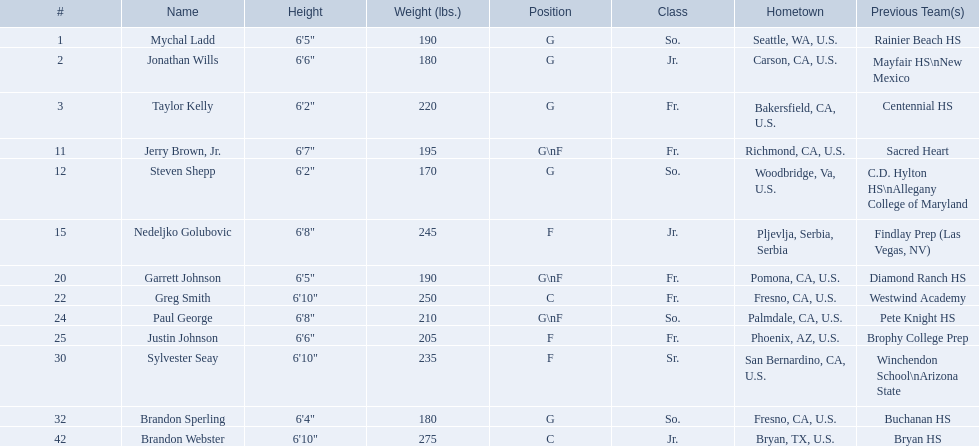What grade level was each team member in during the 2009-10 fresno state bulldogs? So., Jr., Fr., Fr., So., Jr., Fr., Fr., So., Fr., Sr., So., Jr. Which of these members was not from the us? Jr. Who was that player? Nedeljko Golubovic. Which team members play as forwards? Nedeljko Golubovic, Paul George, Justin Johnson, Sylvester Seay. What are their heights? Nedeljko Golubovic, 6'8", Paul George, 6'8", Justin Johnson, 6'6", Sylvester Seay, 6'10". Out of these players, who has the lowest height? Justin Johnson. 